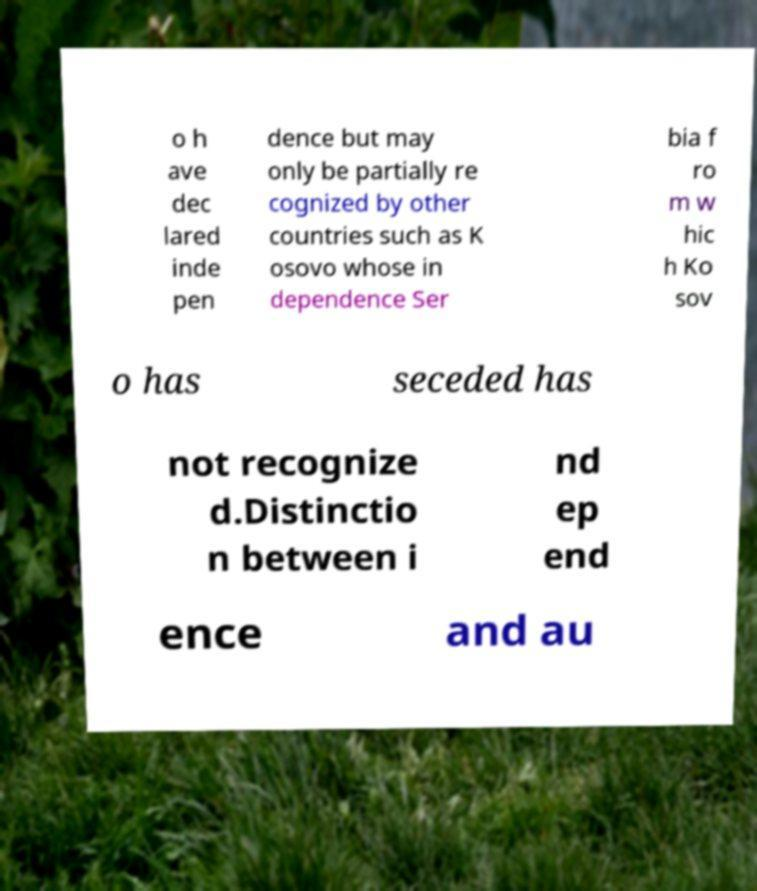Please identify and transcribe the text found in this image. o h ave dec lared inde pen dence but may only be partially re cognized by other countries such as K osovo whose in dependence Ser bia f ro m w hic h Ko sov o has seceded has not recognize d.Distinctio n between i nd ep end ence and au 